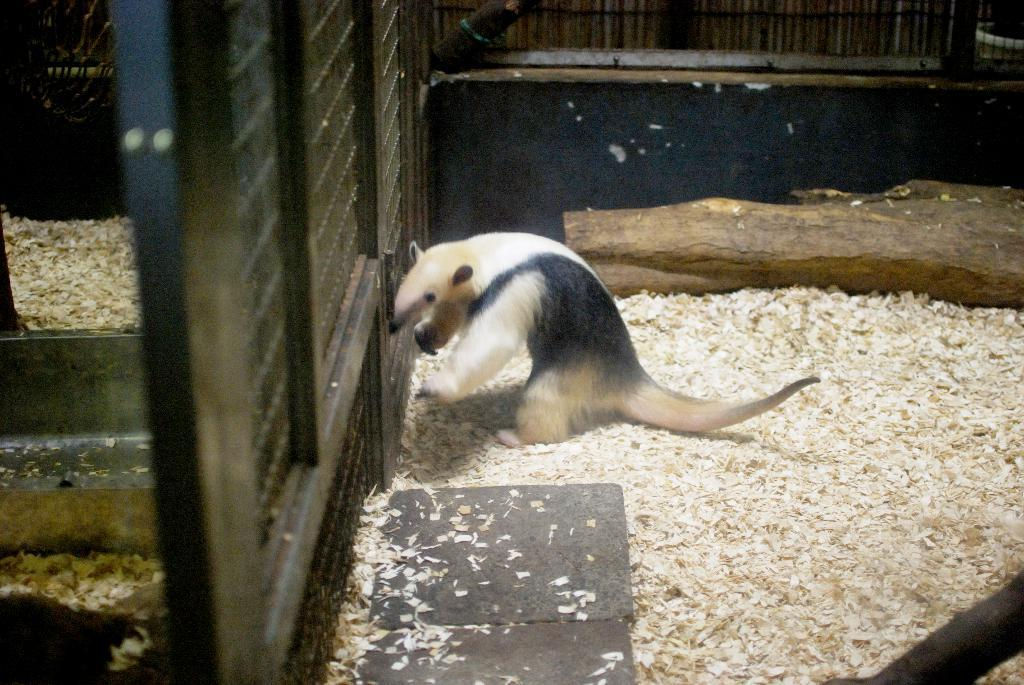What type of animal is in the image? The type of animal cannot be determined from the provided facts. What is the surface beneath the animal in the image? The animal is on sawdust. What is located near the animal in the image? The animal is beside a fence. What other object can be seen in the image? There is a wooden log in the image. What type of flesh can be seen on the animal in the image? There is no flesh visible on the animal in the image, as the animal's type cannot be determined. How does the animal breathe in the image? The animal's breathing cannot be observed in the image, as it is a still image. 